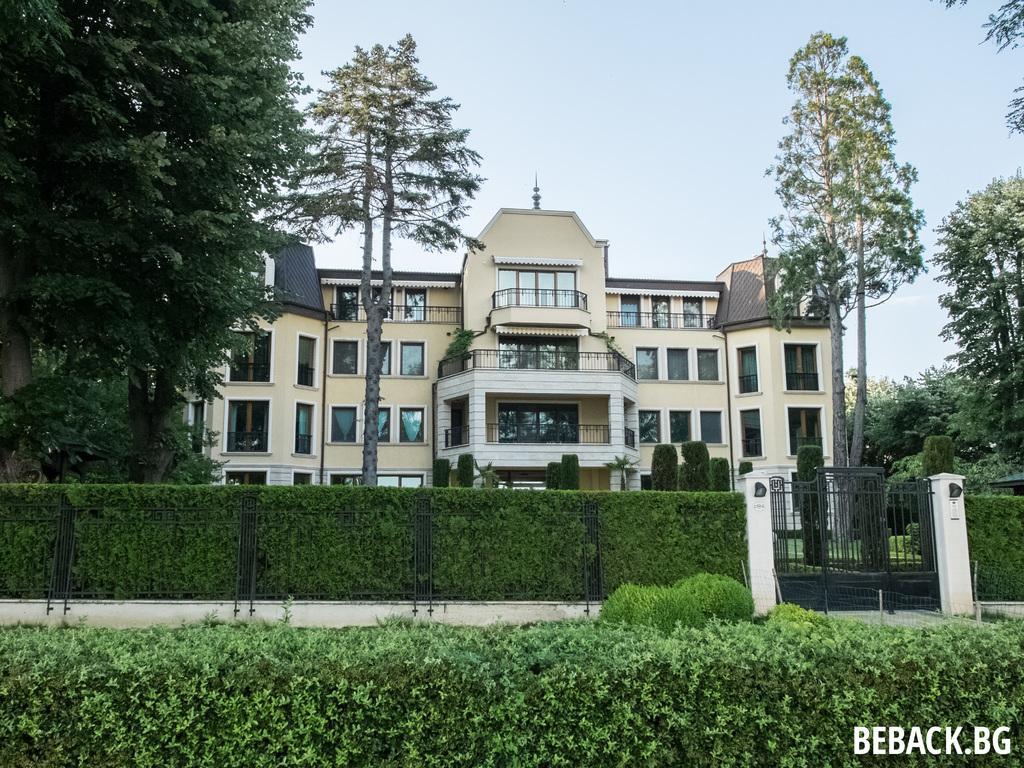Please provide a concise description of this image. At the bottom of the picture, we see the shrubs and behind that, we see a black gate and a fence. In the background, we see a building in white color and there are trees in the background. At the top of the picture, we see the sky. 